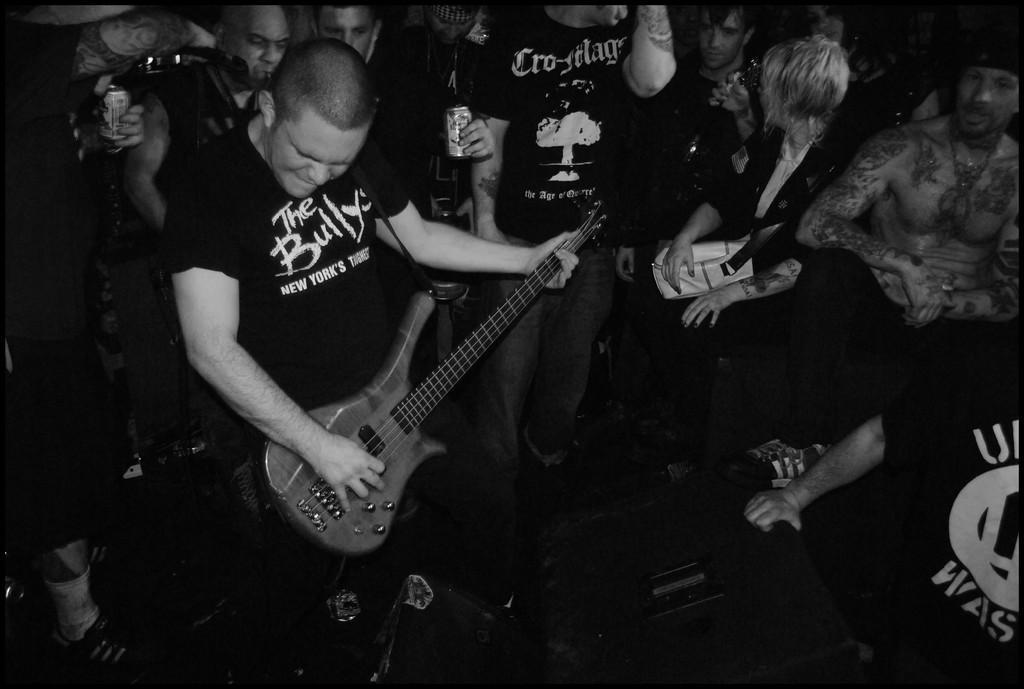Could you give a brief overview of what you see in this image? There are group of people in the image. On left side there is a man standing and playing a guitar, on bottom we can also see a speaker. 